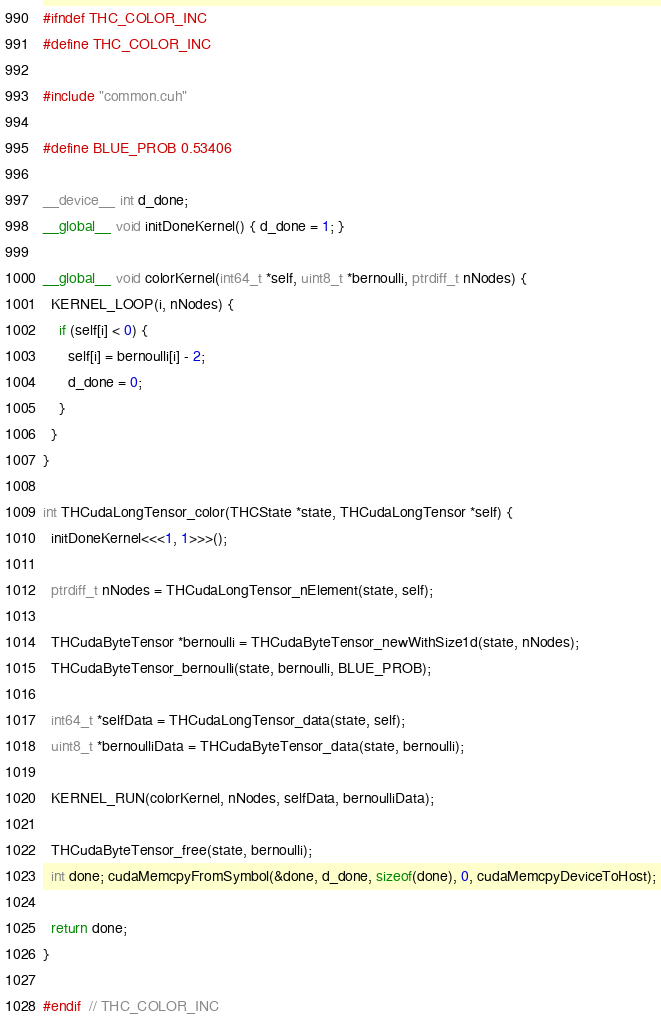Convert code to text. <code><loc_0><loc_0><loc_500><loc_500><_Cuda_>#ifndef THC_COLOR_INC
#define THC_COLOR_INC

#include "common.cuh"

#define BLUE_PROB 0.53406

__device__ int d_done;
__global__ void initDoneKernel() { d_done = 1; }

__global__ void colorKernel(int64_t *self, uint8_t *bernoulli, ptrdiff_t nNodes) {
  KERNEL_LOOP(i, nNodes) {
    if (self[i] < 0) {
      self[i] = bernoulli[i] - 2;
      d_done = 0;
    }
  }
}

int THCudaLongTensor_color(THCState *state, THCudaLongTensor *self) {
  initDoneKernel<<<1, 1>>>();

  ptrdiff_t nNodes = THCudaLongTensor_nElement(state, self);

  THCudaByteTensor *bernoulli = THCudaByteTensor_newWithSize1d(state, nNodes);
  THCudaByteTensor_bernoulli(state, bernoulli, BLUE_PROB);

  int64_t *selfData = THCudaLongTensor_data(state, self);
  uint8_t *bernoulliData = THCudaByteTensor_data(state, bernoulli);

  KERNEL_RUN(colorKernel, nNodes, selfData, bernoulliData);

  THCudaByteTensor_free(state, bernoulli);
  int done; cudaMemcpyFromSymbol(&done, d_done, sizeof(done), 0, cudaMemcpyDeviceToHost);

  return done;
}

#endif  // THC_COLOR_INC
</code> 